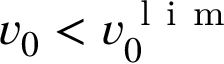Convert formula to latex. <formula><loc_0><loc_0><loc_500><loc_500>v _ { 0 } < v _ { 0 } ^ { l i m }</formula> 